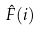Convert formula to latex. <formula><loc_0><loc_0><loc_500><loc_500>\hat { F } ( i )</formula> 